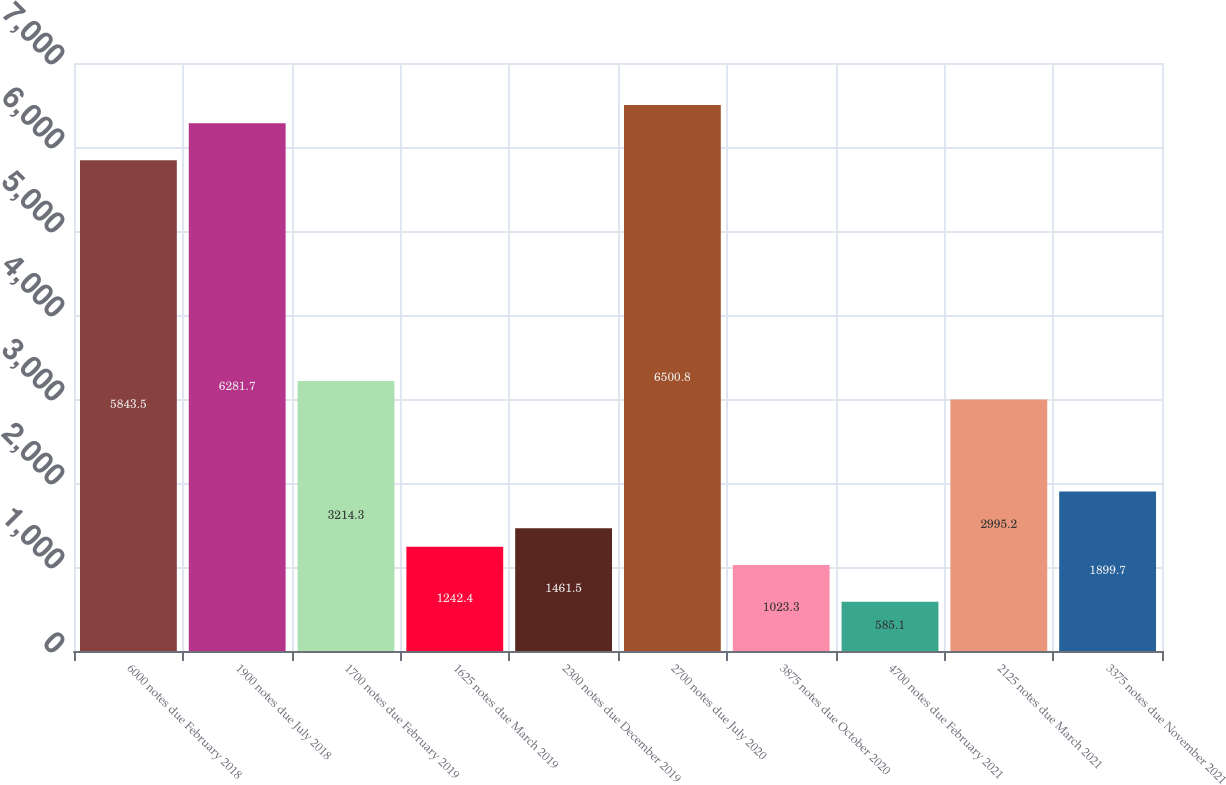<chart> <loc_0><loc_0><loc_500><loc_500><bar_chart><fcel>6000 notes due February 2018<fcel>1900 notes due July 2018<fcel>1700 notes due February 2019<fcel>1625 notes due March 2019<fcel>2300 notes due December 2019<fcel>2700 notes due July 2020<fcel>3875 notes due October 2020<fcel>4700 notes due February 2021<fcel>2125 notes due March 2021<fcel>3375 notes due November 2021<nl><fcel>5843.5<fcel>6281.7<fcel>3214.3<fcel>1242.4<fcel>1461.5<fcel>6500.8<fcel>1023.3<fcel>585.1<fcel>2995.2<fcel>1899.7<nl></chart> 